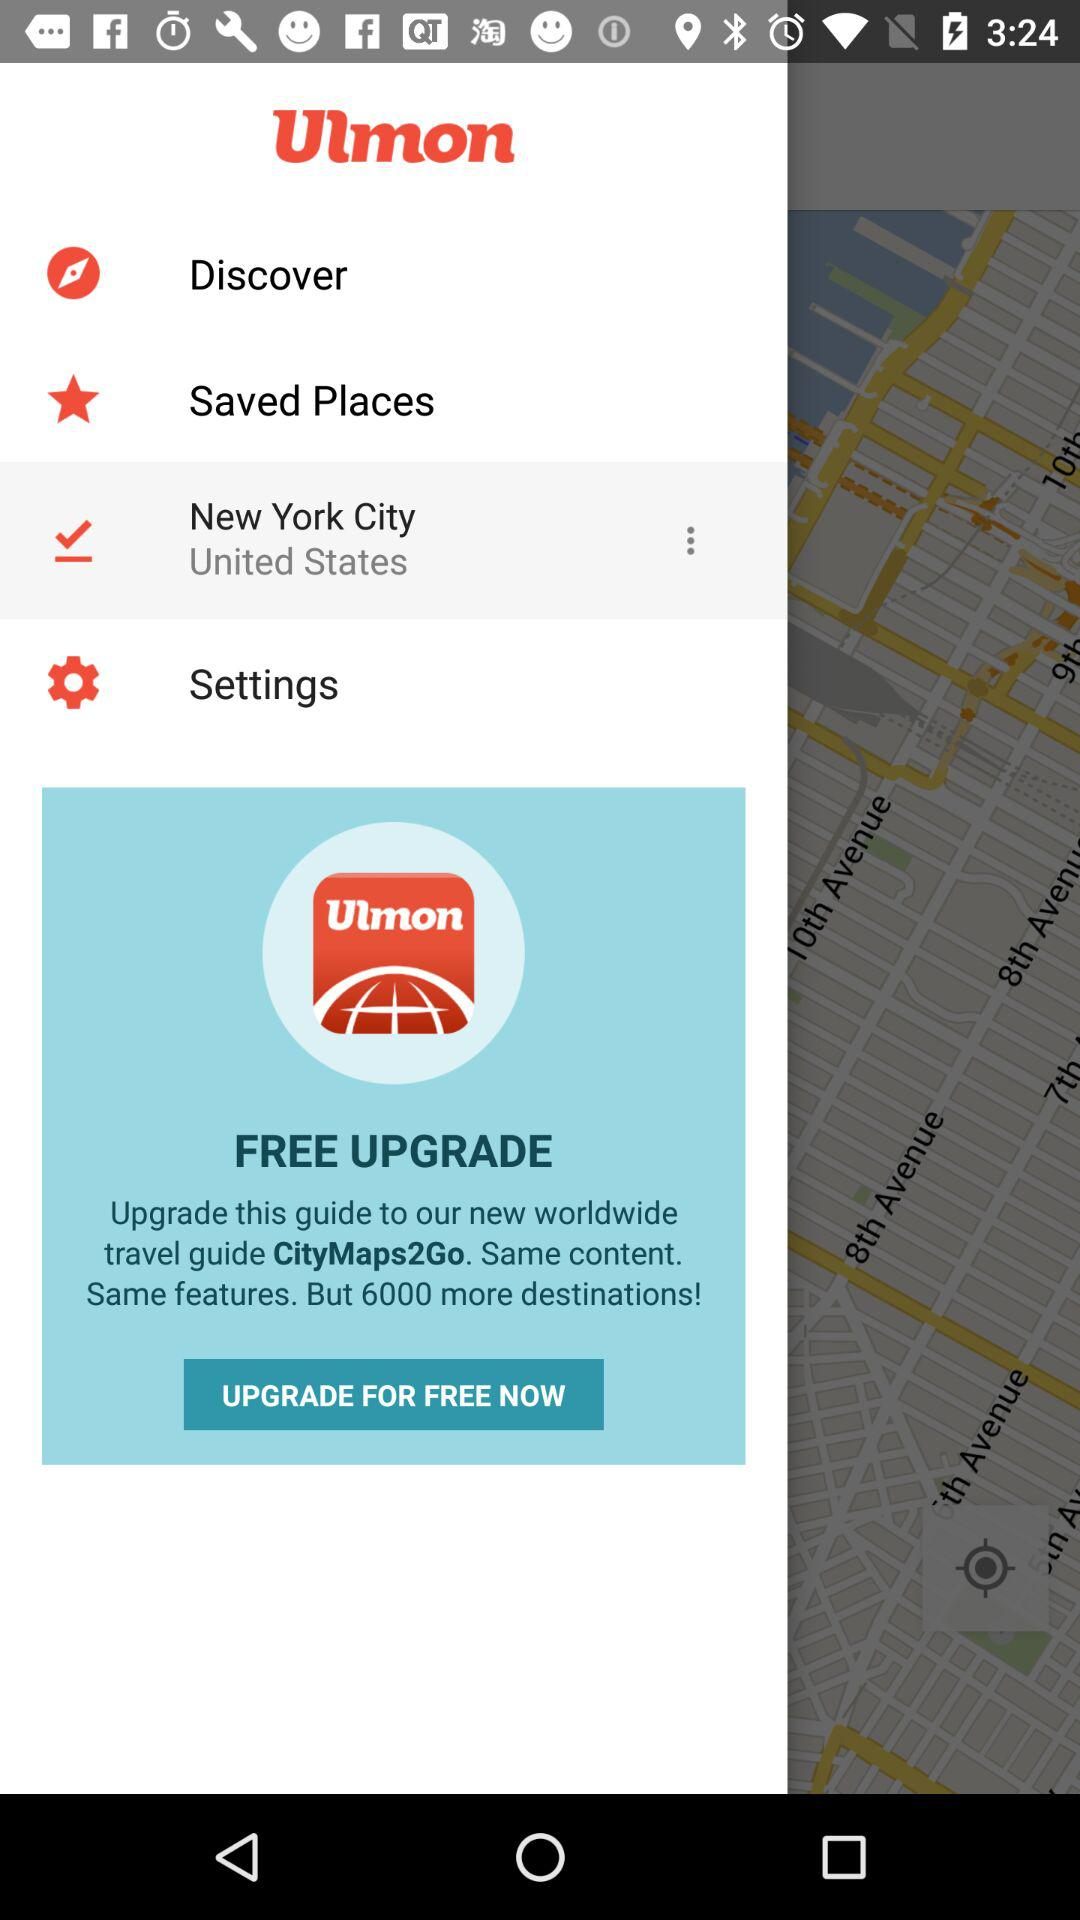How many more destinations does the new CityMaps2Go guide have than the current Ulmon guide?
Answer the question using a single word or phrase. 6000 